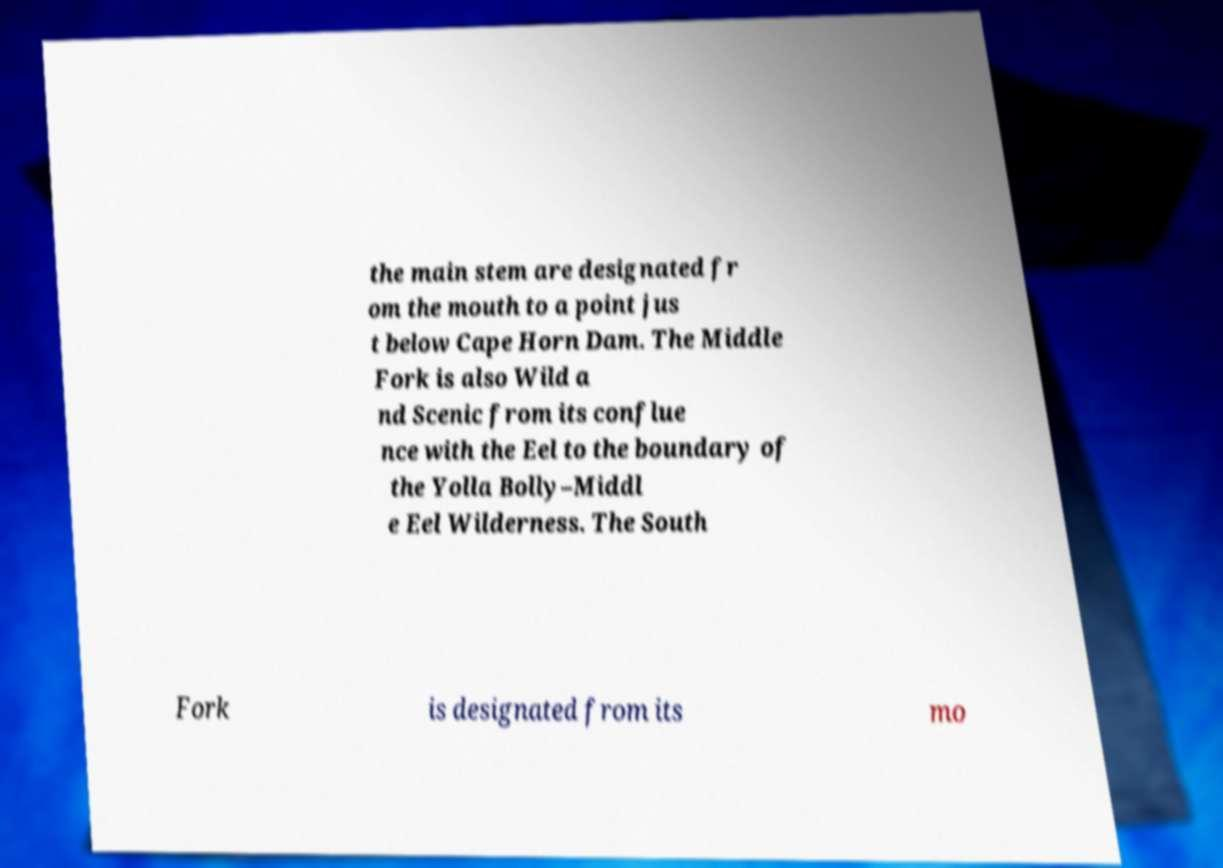What messages or text are displayed in this image? I need them in a readable, typed format. the main stem are designated fr om the mouth to a point jus t below Cape Horn Dam. The Middle Fork is also Wild a nd Scenic from its conflue nce with the Eel to the boundary of the Yolla Bolly–Middl e Eel Wilderness. The South Fork is designated from its mo 